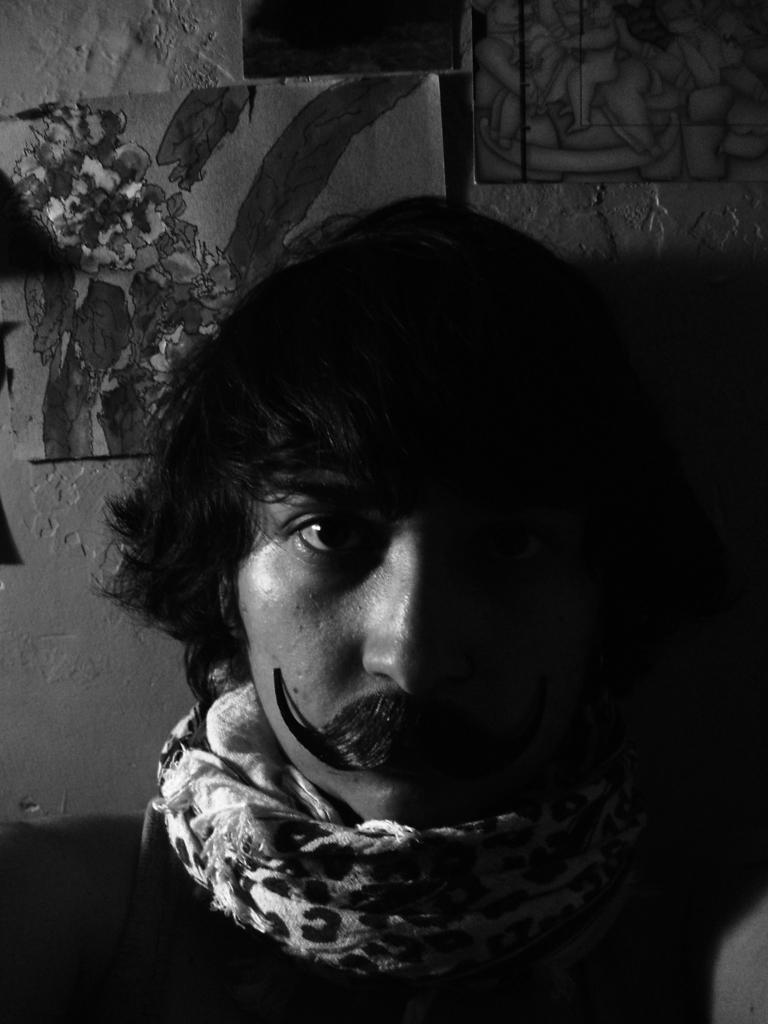What is the main subject of the image? There is a person in the image. What can be seen on the wall in the image? There are frames attached to the wall in the image. What color scheme is used in the image? The image is in black and white color. Can you see any ghosts interacting with the person in the image? There are no ghosts present in the image. What type of powder is being used by the person in the image? There is no powder visible in the image. 